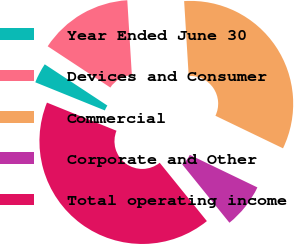Convert chart. <chart><loc_0><loc_0><loc_500><loc_500><pie_chart><fcel>Year Ended June 30<fcel>Devices and Consumer<fcel>Commercial<fcel>Corporate and Other<fcel>Total operating income<nl><fcel>3.15%<fcel>14.76%<fcel>33.11%<fcel>7.03%<fcel>41.94%<nl></chart> 